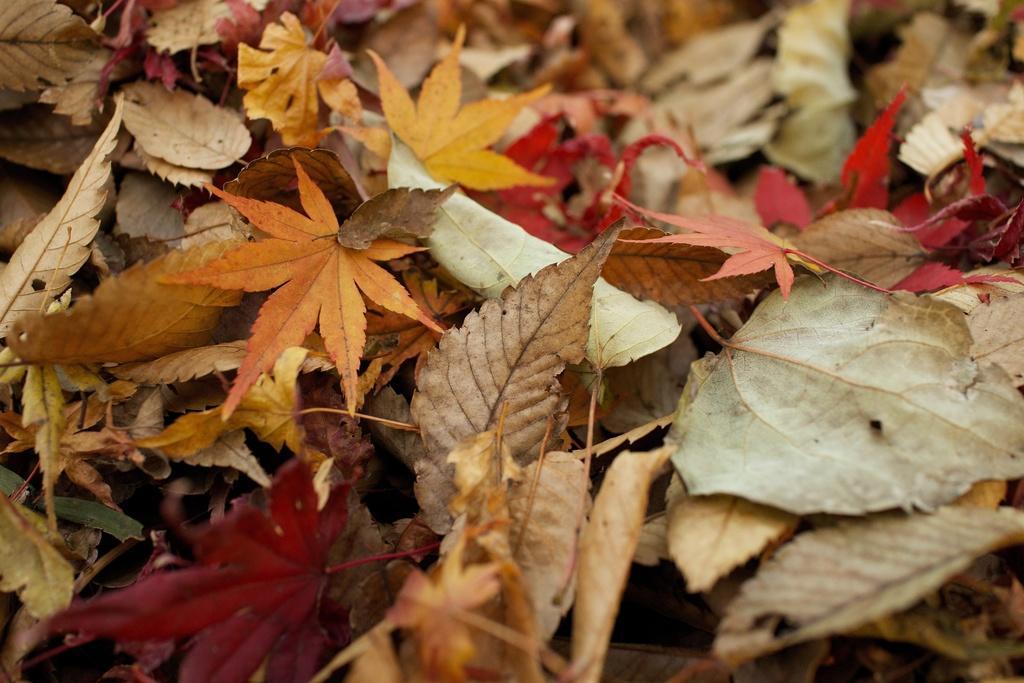In one or two sentences, can you explain what this image depicts? In this image we can see some leaves which are in different colors on the ground. 